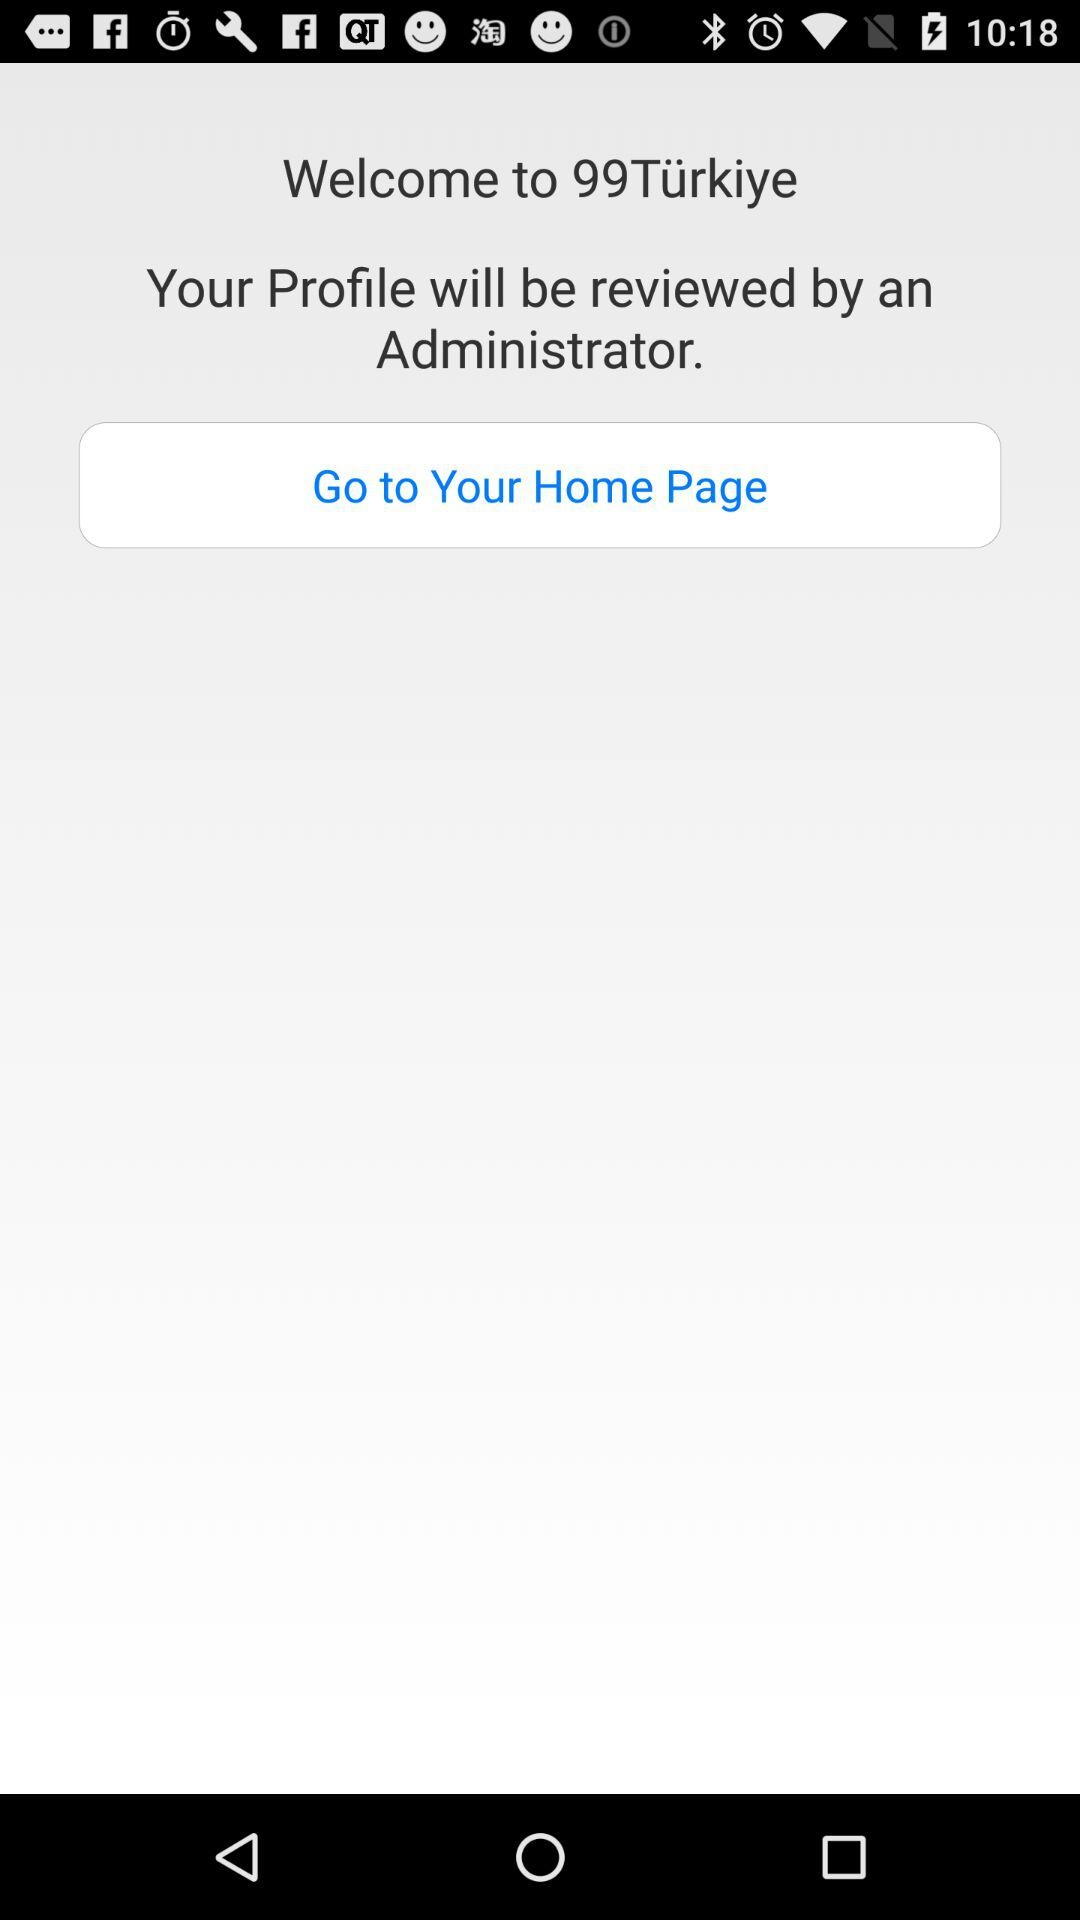What is the application name? The application name is "99Türkiye". 